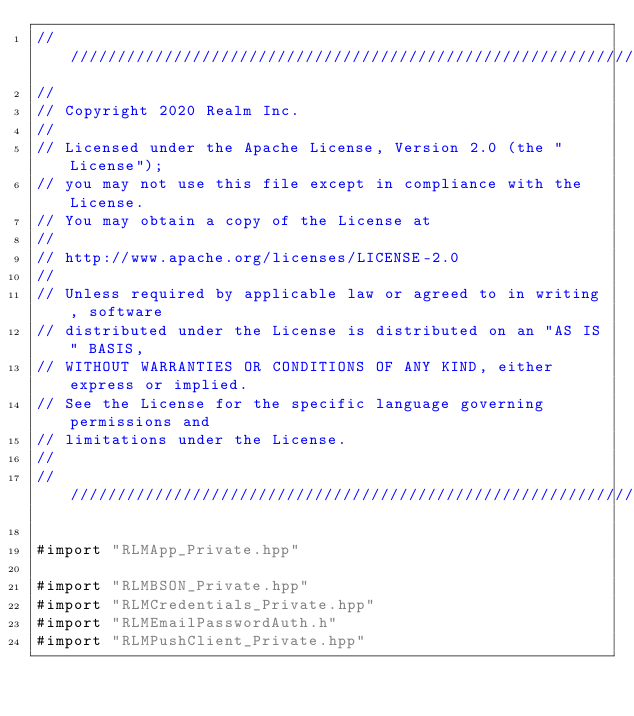<code> <loc_0><loc_0><loc_500><loc_500><_ObjectiveC_>////////////////////////////////////////////////////////////////////////////
//
// Copyright 2020 Realm Inc.
//
// Licensed under the Apache License, Version 2.0 (the "License");
// you may not use this file except in compliance with the License.
// You may obtain a copy of the License at
//
// http://www.apache.org/licenses/LICENSE-2.0
//
// Unless required by applicable law or agreed to in writing, software
// distributed under the License is distributed on an "AS IS" BASIS,
// WITHOUT WARRANTIES OR CONDITIONS OF ANY KIND, either express or implied.
// See the License for the specific language governing permissions and
// limitations under the License.
//
////////////////////////////////////////////////////////////////////////////

#import "RLMApp_Private.hpp"

#import "RLMBSON_Private.hpp"
#import "RLMCredentials_Private.hpp"
#import "RLMEmailPasswordAuth.h"
#import "RLMPushClient_Private.hpp"</code> 